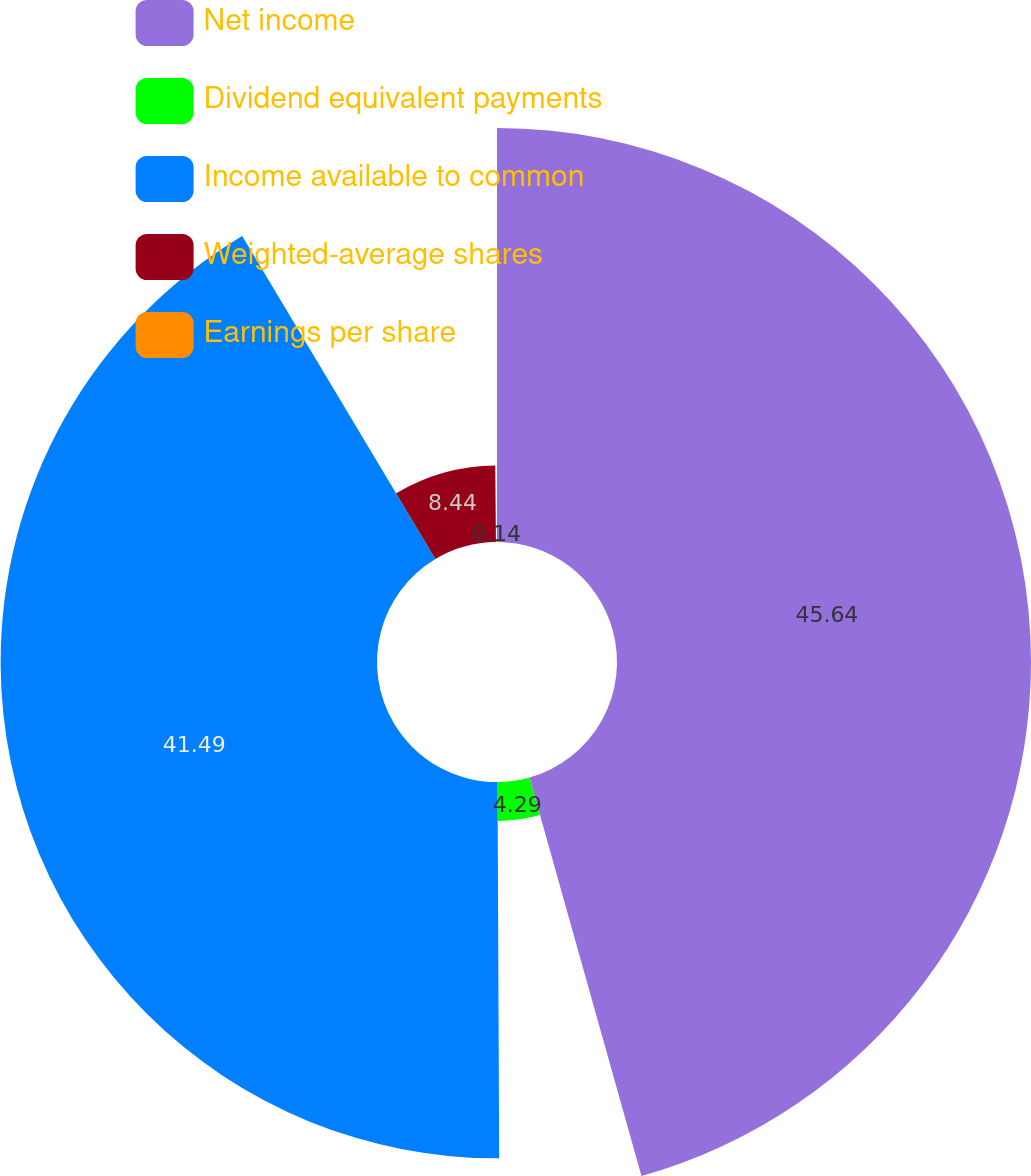<chart> <loc_0><loc_0><loc_500><loc_500><pie_chart><fcel>Net income<fcel>Dividend equivalent payments<fcel>Income available to common<fcel>Weighted-average shares<fcel>Earnings per share<nl><fcel>45.64%<fcel>4.29%<fcel>41.49%<fcel>8.44%<fcel>0.14%<nl></chart> 